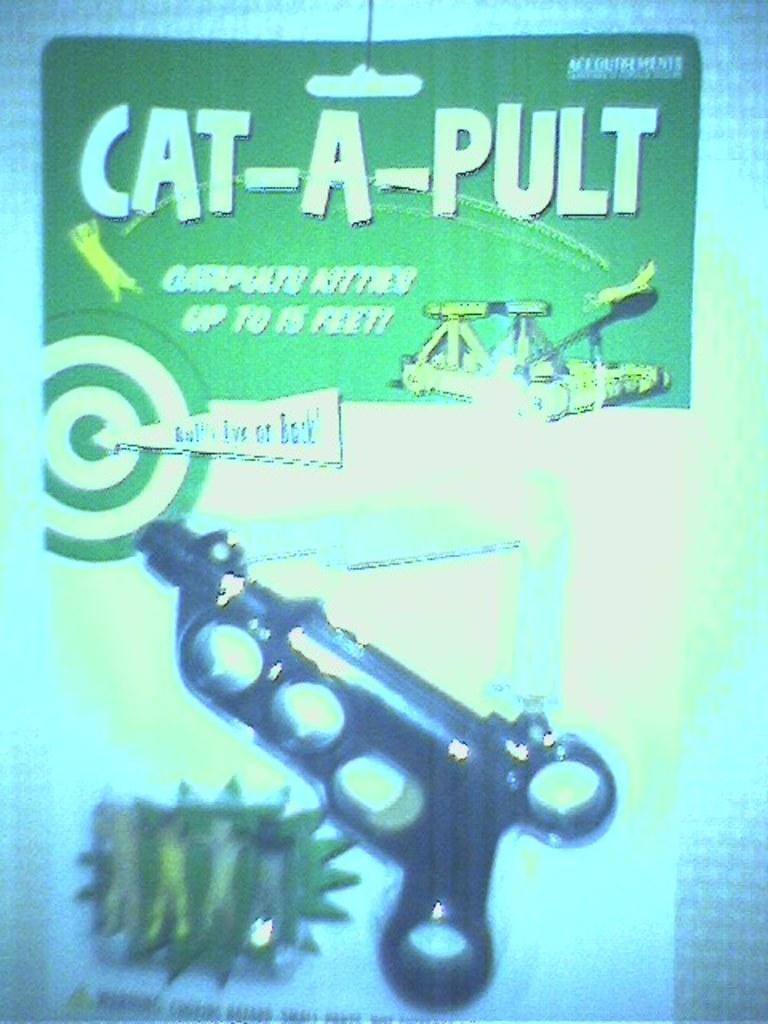<image>
Give a short and clear explanation of the subsequent image. Box for a toy gun that says "Cat-A-Pult" on the top. 